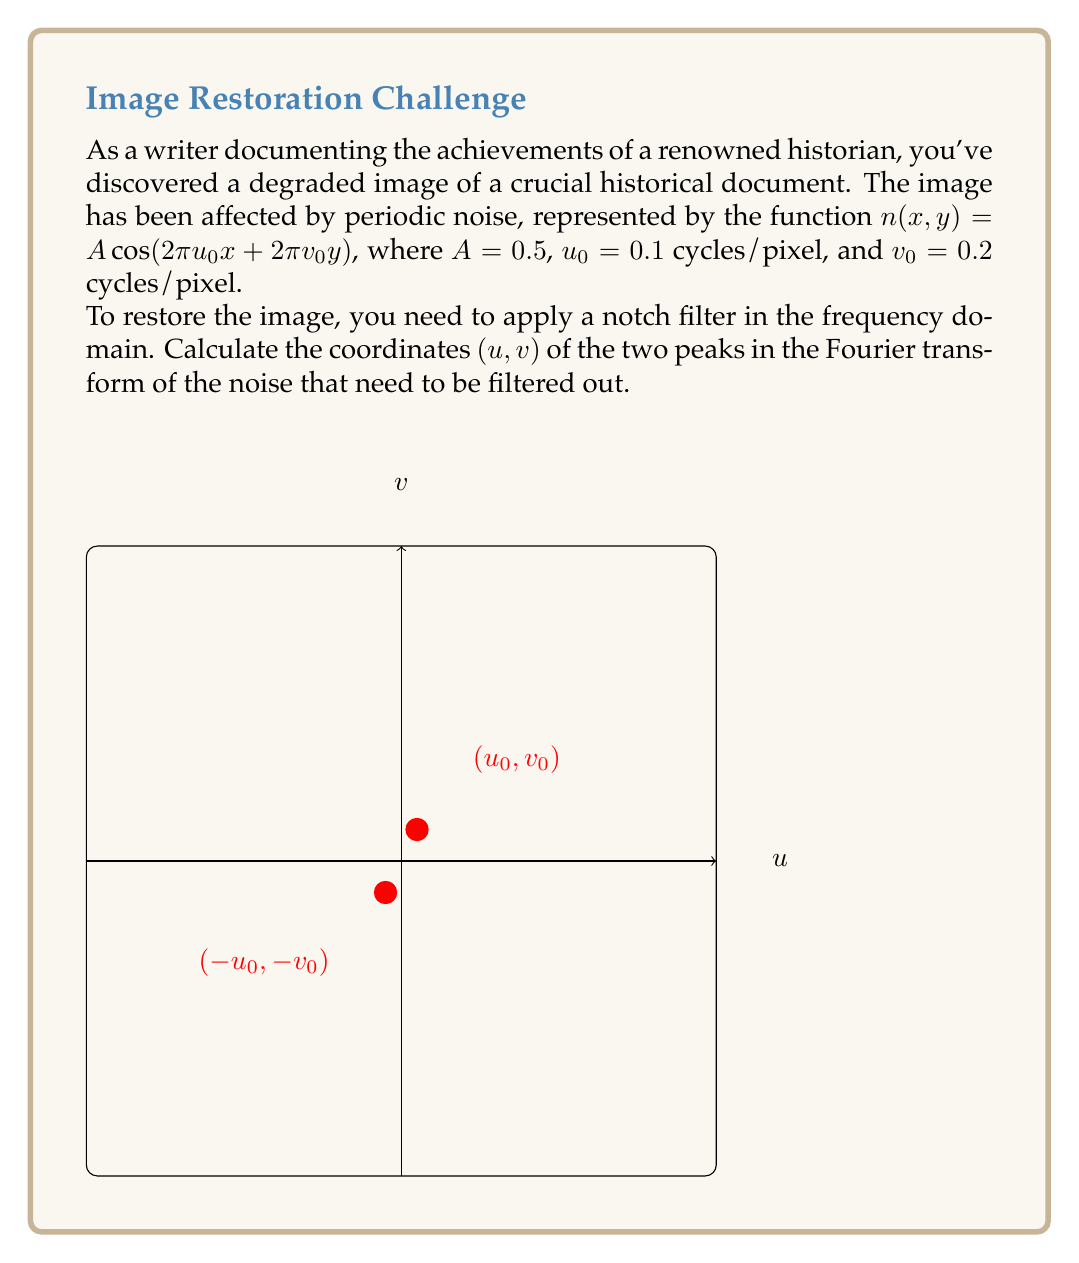Provide a solution to this math problem. To solve this problem, we need to understand how periodic noise appears in the frequency domain:

1) The Fourier transform of a cosine function results in two symmetric peaks in the frequency domain.

2) The general form of 2D periodic noise is:
   $$n(x,y) = A \cos(2\pi u_0 x + 2\pi v_0 y)$$

3) In the frequency domain, this noise will appear as two delta functions at coordinates $(u_0, v_0)$ and $(-u_0, -v_0)$.

4) Given:
   $A = 0.5$
   $u_0 = 0.1$ cycles/pixel
   $v_0 = 0.2$ cycles/pixel

5) Therefore, the two peaks in the Fourier transform of the noise will be located at:
   Peak 1: $(u_0, v_0) = (0.1, 0.2)$
   Peak 2: $(-u_0, -v_0) = (-0.1, -0.2)$

6) These are the coordinates where we need to apply the notch filter to remove the periodic noise from the image.

Note: The amplitude $A$ doesn't affect the position of the peaks in the frequency domain, only their intensity.
Answer: $(0.1, 0.2)$ and $(-0.1, -0.2)$ 